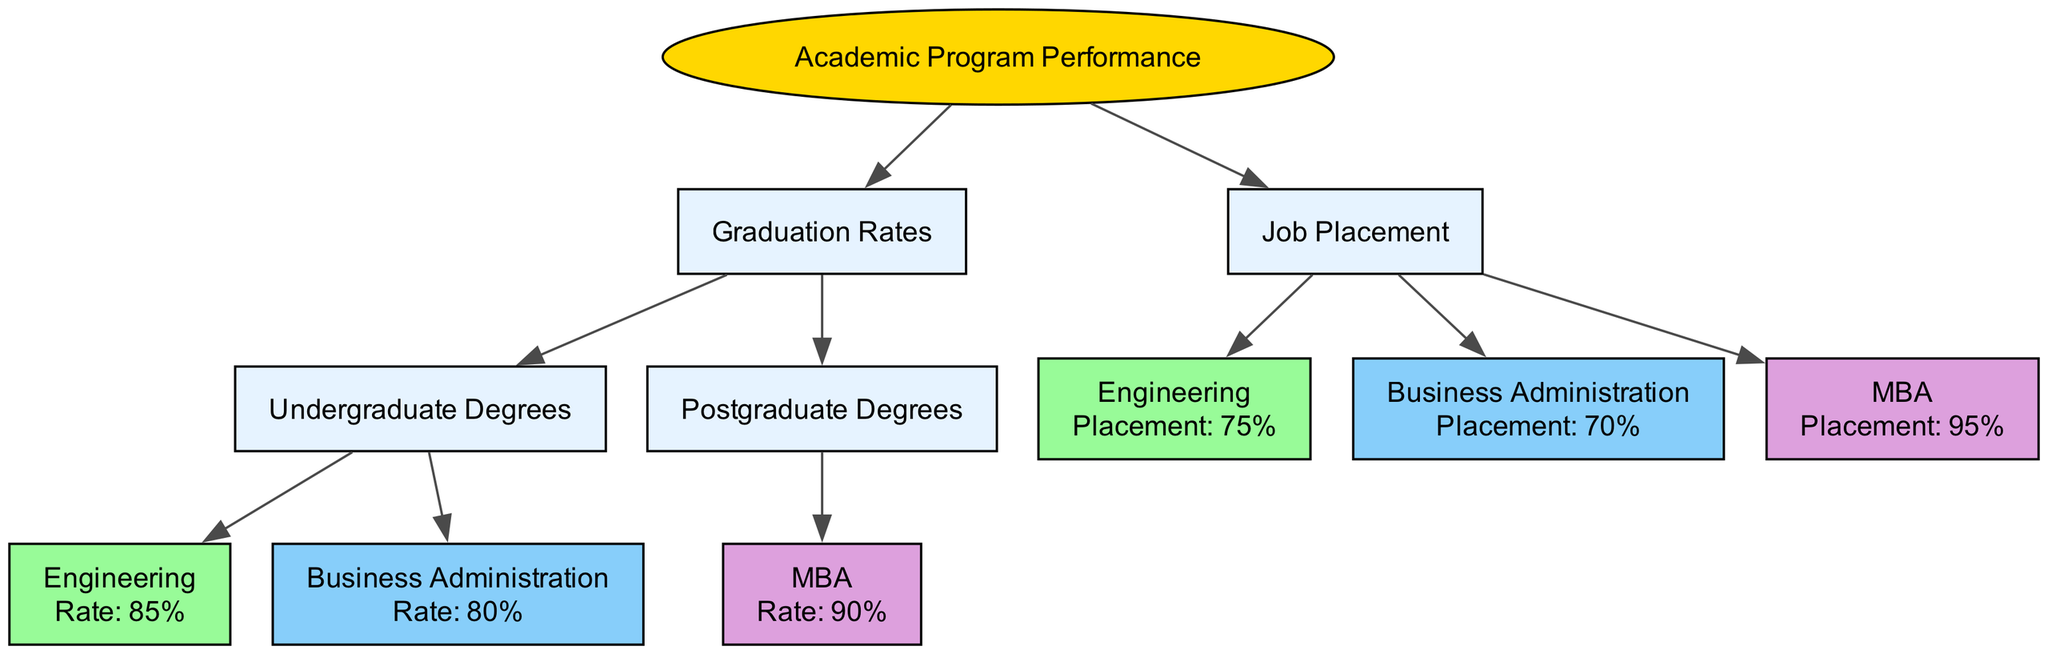What is the graduation rate for the Engineering program? The diagram shows a node for the Engineering program under the Graduation Rates category, which states that the rate is 85%.
Answer: 85% What is the placement rate for the MBA program? The diagram includes a node for the MBA program under Job Placement, which indicates a placement rate of 95%.
Answer: 95% How many undergraduate programs are listed in the diagram? The diagram features two nodes under the Undergraduate Degrees subsection: Engineering and Business Administration. Therefore, there are two undergraduate programs listed.
Answer: 2 What are the factors contributing to the Engineering graduation rate? Referring to the Engineering program node, it lists two factors that are crucial: High Student Engagement and High Financial Aid Availability, which are further explained under each factor.
Answer: High Student Engagement, High Financial Aid Availability Which undergraduate program has a higher job placement rate, Engineering or Business Administration? The diagram provides the placement rate for Engineering as 75% and for Business Administration as 70%. Therefore, Engineering has a higher job placement rate than Business Administration.
Answer: Engineering What primary metrics does the tree assess under Academic Program Performance? The two primary metrics identified in the root node of the diagram are Graduation Rates and Job Placement.
Answer: Graduation Rates, Job Placement Is the Business Administration graduation rate influenced by active industry partnerships? In the diagram, a node under Business Administration specifically states that active industry partnerships are a contributing factor to its graduation rate of 80%. Hence, yes, it is influenced by active industry partnerships.
Answer: Yes How does the MBA program rate in terms of employer satisfaction? The diagram does not provide any information about employer satisfaction for the MBA program, as all related metrics focus solely on placement rate and alumni success. Therefore, it cannot be determined.
Answer: Not available What is the total number of nodes under Job Placement in the diagram? There are three nodes under Job Placement: Engineering, Business Administration, and MBA. Therefore, there are three total nodes under this category.
Answer: 3 